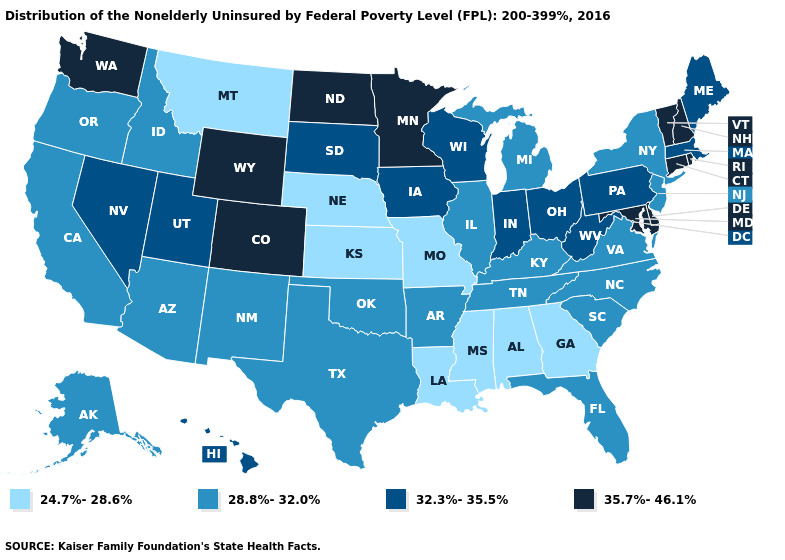Which states have the highest value in the USA?
Short answer required. Colorado, Connecticut, Delaware, Maryland, Minnesota, New Hampshire, North Dakota, Rhode Island, Vermont, Washington, Wyoming. What is the value of Missouri?
Be succinct. 24.7%-28.6%. Which states have the lowest value in the USA?
Give a very brief answer. Alabama, Georgia, Kansas, Louisiana, Mississippi, Missouri, Montana, Nebraska. What is the value of Missouri?
Write a very short answer. 24.7%-28.6%. Name the states that have a value in the range 32.3%-35.5%?
Short answer required. Hawaii, Indiana, Iowa, Maine, Massachusetts, Nevada, Ohio, Pennsylvania, South Dakota, Utah, West Virginia, Wisconsin. Name the states that have a value in the range 32.3%-35.5%?
Short answer required. Hawaii, Indiana, Iowa, Maine, Massachusetts, Nevada, Ohio, Pennsylvania, South Dakota, Utah, West Virginia, Wisconsin. What is the lowest value in the South?
Concise answer only. 24.7%-28.6%. Does the first symbol in the legend represent the smallest category?
Quick response, please. Yes. What is the value of Indiana?
Give a very brief answer. 32.3%-35.5%. What is the value of New Hampshire?
Quick response, please. 35.7%-46.1%. Does North Dakota have the highest value in the USA?
Give a very brief answer. Yes. Is the legend a continuous bar?
Give a very brief answer. No. Does South Dakota have the same value as Iowa?
Write a very short answer. Yes. Among the states that border New Mexico , which have the lowest value?
Concise answer only. Arizona, Oklahoma, Texas. Name the states that have a value in the range 28.8%-32.0%?
Quick response, please. Alaska, Arizona, Arkansas, California, Florida, Idaho, Illinois, Kentucky, Michigan, New Jersey, New Mexico, New York, North Carolina, Oklahoma, Oregon, South Carolina, Tennessee, Texas, Virginia. 